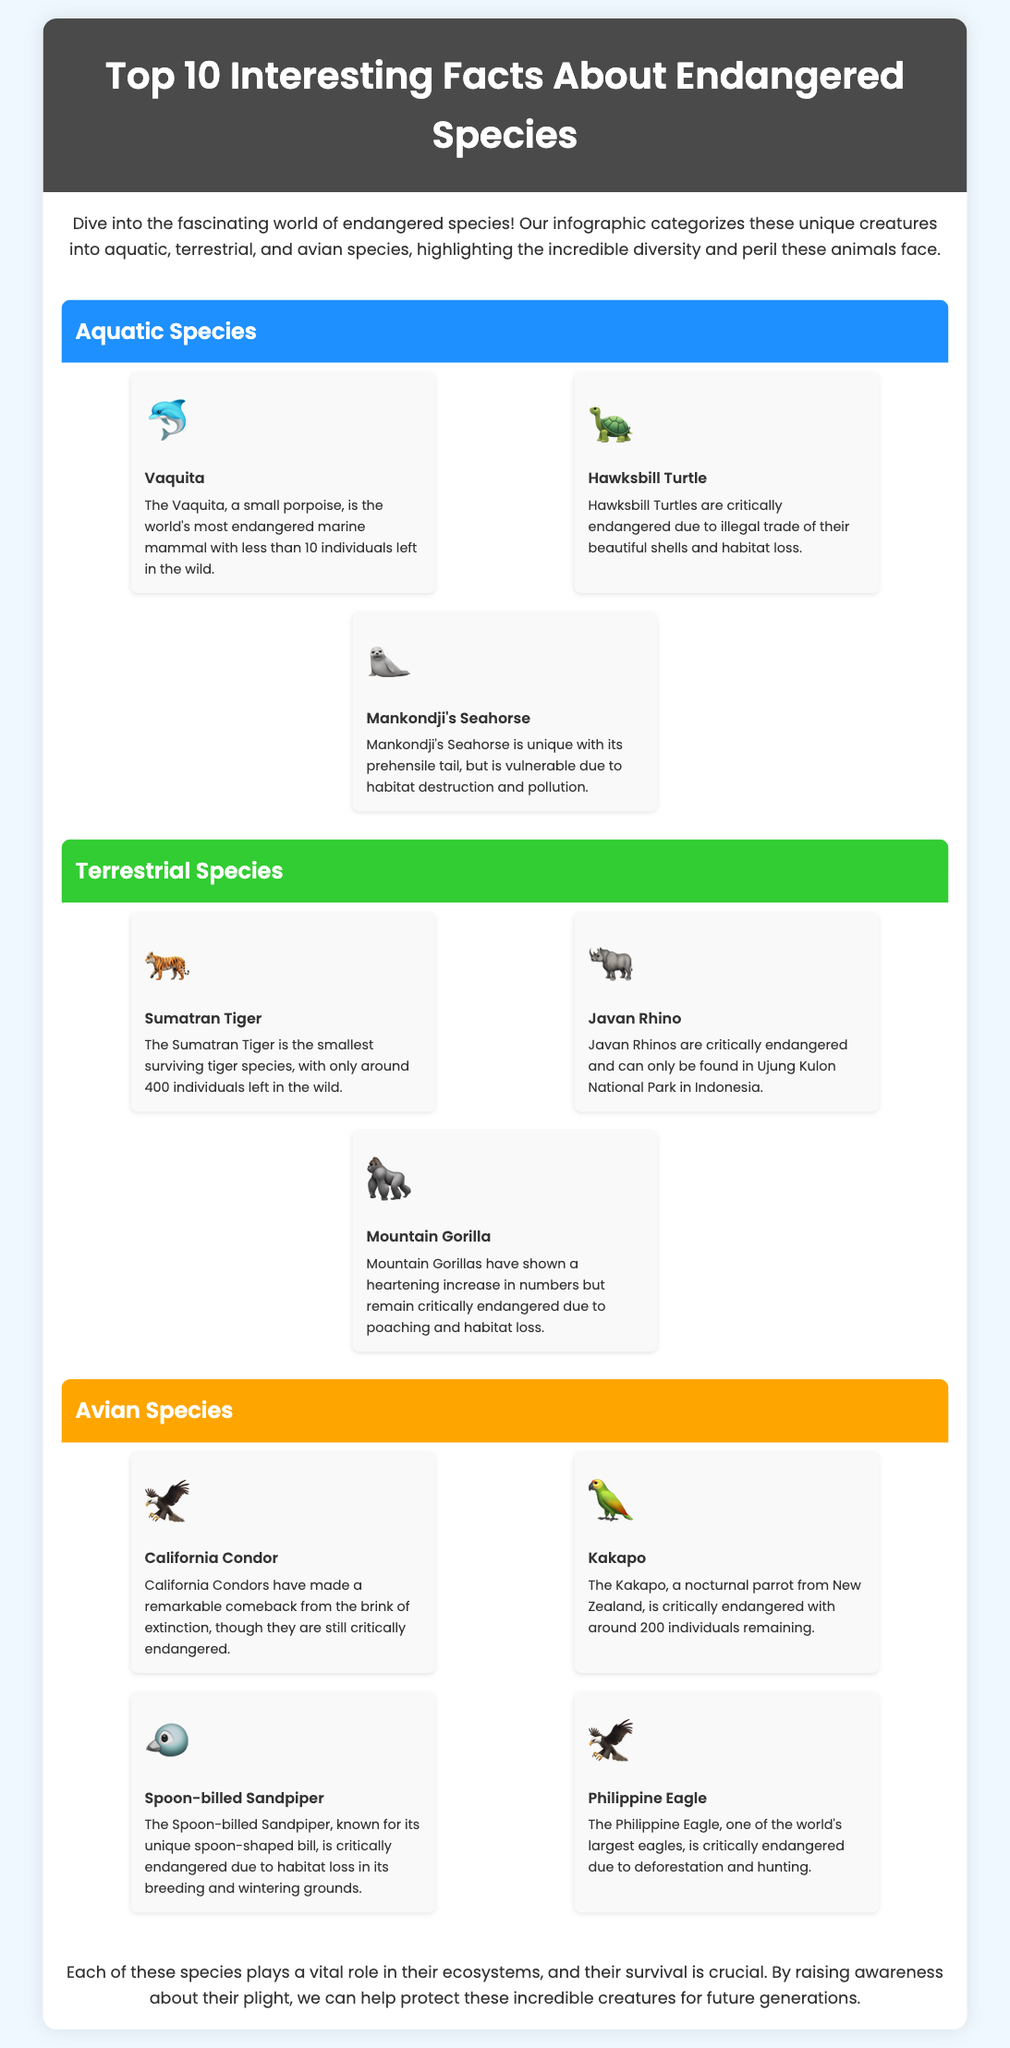What is the most endangered marine mammal? The document states that the Vaquita is the world's most endangered marine mammal with less than 10 individuals left in the wild.
Answer: Vaquita How many Sumatran Tigers are left in the wild? According to the infographic, only around 400 Sumatran Tigers remain in the wild.
Answer: 400 What is the unique feature of Mankondji's Seahorse? The unique feature mentioned is its prehensile tail, which helps it adapt to its environment.
Answer: Prehensile tail Which avian species has made a remarkable comeback? The California Condor is noted for its significant recovery from near extinction but remains critically endangered.
Answer: California Condor What color represents terrestrial species in the infographic? The background color for terrestrial species is described as green.
Answer: Green How many Kakapos are remaining? The infographic notes that there are about 200 Kakapos remaining, indicating their critical endangerment.
Answer: 200 What role do endangered species play in their ecosystems? The document explains that each species plays a vital role in their ecosystems, emphasizing their importance.
Answer: Vital role Why are Hawksbill Turtles critically endangered? The main reasons given for their critical endangerment are illegal trade and habitat loss.
Answer: Illegal trade and habitat loss Where is the Javan Rhino found? The Javan Rhino can only be found in Ujung Kulon National Park in Indonesia, as stated in the document.
Answer: Ujung Kulon National Park What is the significance of raising awareness about endangered species? Raising awareness is crucial to help protect these incredible creatures for future generations.
Answer: Protect these incredible creatures 